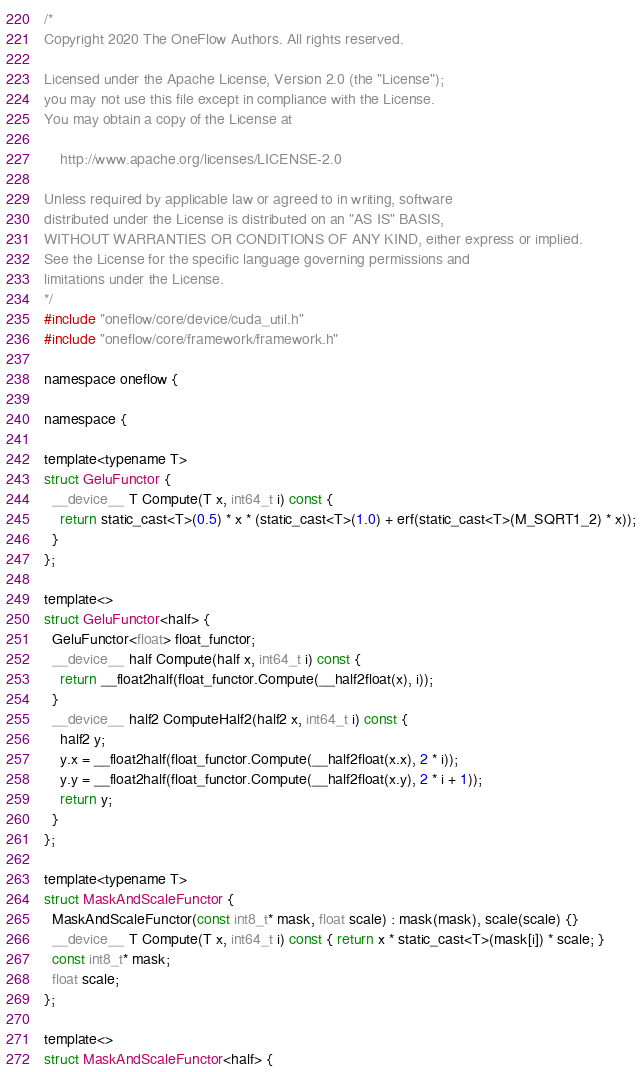<code> <loc_0><loc_0><loc_500><loc_500><_Cuda_>/*
Copyright 2020 The OneFlow Authors. All rights reserved.

Licensed under the Apache License, Version 2.0 (the "License");
you may not use this file except in compliance with the License.
You may obtain a copy of the License at

    http://www.apache.org/licenses/LICENSE-2.0

Unless required by applicable law or agreed to in writing, software
distributed under the License is distributed on an "AS IS" BASIS,
WITHOUT WARRANTIES OR CONDITIONS OF ANY KIND, either express or implied.
See the License for the specific language governing permissions and
limitations under the License.
*/
#include "oneflow/core/device/cuda_util.h"
#include "oneflow/core/framework/framework.h"

namespace oneflow {

namespace {

template<typename T>
struct GeluFunctor {
  __device__ T Compute(T x, int64_t i) const {
    return static_cast<T>(0.5) * x * (static_cast<T>(1.0) + erf(static_cast<T>(M_SQRT1_2) * x));
  }
};

template<>
struct GeluFunctor<half> {
  GeluFunctor<float> float_functor;
  __device__ half Compute(half x, int64_t i) const {
    return __float2half(float_functor.Compute(__half2float(x), i));
  }
  __device__ half2 ComputeHalf2(half2 x, int64_t i) const {
    half2 y;
    y.x = __float2half(float_functor.Compute(__half2float(x.x), 2 * i));
    y.y = __float2half(float_functor.Compute(__half2float(x.y), 2 * i + 1));
    return y;
  }
};

template<typename T>
struct MaskAndScaleFunctor {
  MaskAndScaleFunctor(const int8_t* mask, float scale) : mask(mask), scale(scale) {}
  __device__ T Compute(T x, int64_t i) const { return x * static_cast<T>(mask[i]) * scale; }
  const int8_t* mask;
  float scale;
};

template<>
struct MaskAndScaleFunctor<half> {</code> 